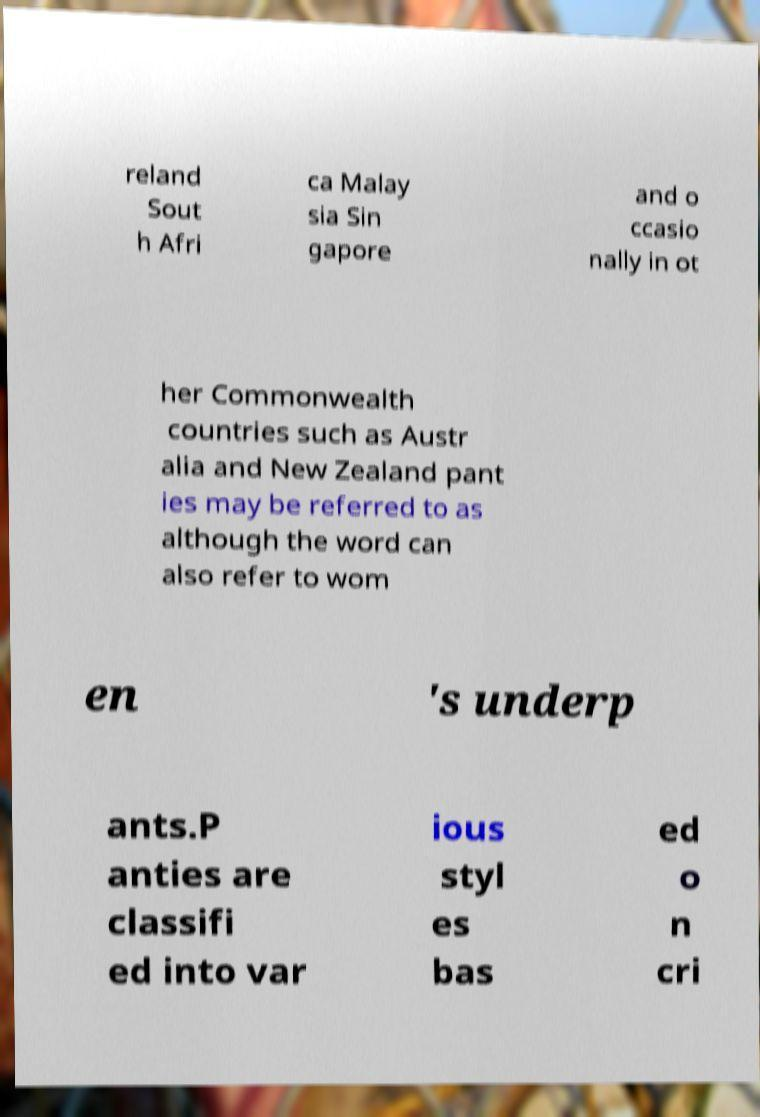For documentation purposes, I need the text within this image transcribed. Could you provide that? reland Sout h Afri ca Malay sia Sin gapore and o ccasio nally in ot her Commonwealth countries such as Austr alia and New Zealand pant ies may be referred to as although the word can also refer to wom en 's underp ants.P anties are classifi ed into var ious styl es bas ed o n cri 